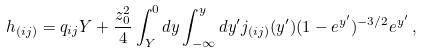<formula> <loc_0><loc_0><loc_500><loc_500>h _ { ( i j ) } = q _ { i j } Y + \frac { z _ { 0 } ^ { 2 } } { 4 } \int _ { Y } ^ { 0 } d y \int _ { - \infty } ^ { y } d y ^ { \prime } j _ { ( i j ) } ( y ^ { \prime } ) ( 1 - e ^ { y ^ { \prime } } ) ^ { - 3 / 2 } e ^ { y ^ { \prime } } \, ,</formula> 